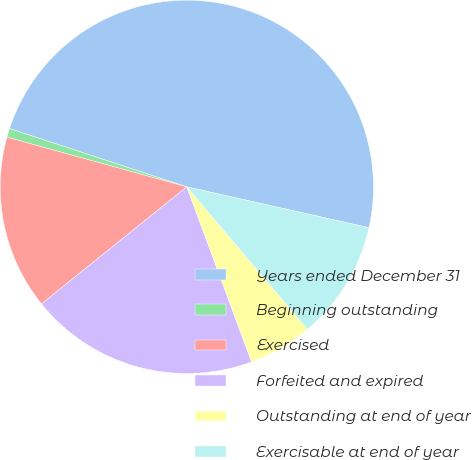<chart> <loc_0><loc_0><loc_500><loc_500><pie_chart><fcel>Years ended December 31<fcel>Beginning outstanding<fcel>Exercised<fcel>Forfeited and expired<fcel>Outstanding at end of year<fcel>Exercisable at end of year<nl><fcel>48.46%<fcel>0.77%<fcel>15.08%<fcel>19.85%<fcel>5.54%<fcel>10.31%<nl></chart> 